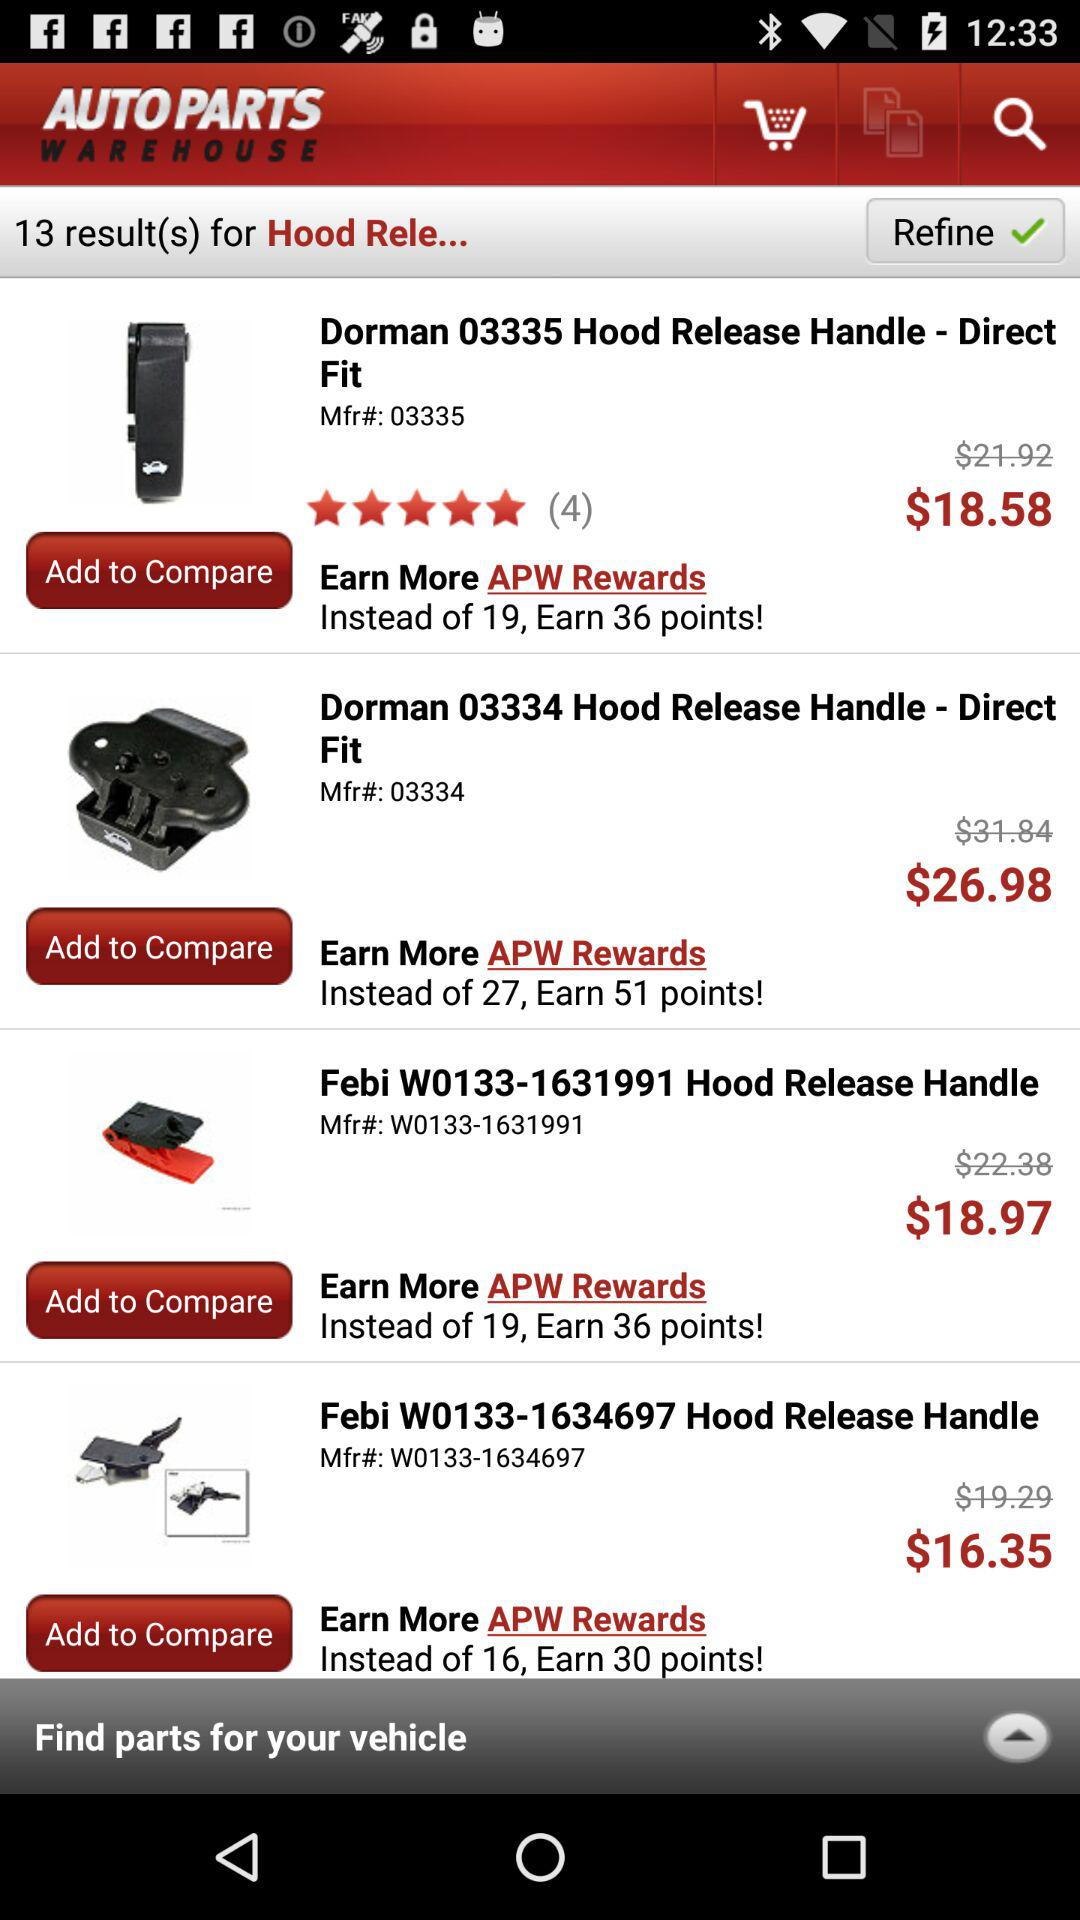What is the price of the "Dorman 03335 Hood Release Handle"? The price is $18.58. 